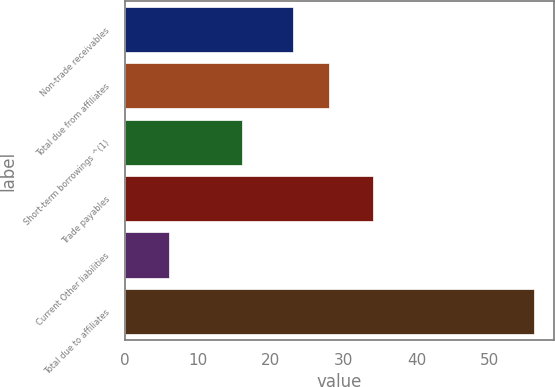Convert chart to OTSL. <chart><loc_0><loc_0><loc_500><loc_500><bar_chart><fcel>Non-trade receivables<fcel>Total due from affiliates<fcel>Short-term borrowings ^(1)<fcel>Trade payables<fcel>Current Other liabilities<fcel>Total due to affiliates<nl><fcel>23<fcel>28<fcel>16<fcel>34<fcel>6<fcel>56<nl></chart> 